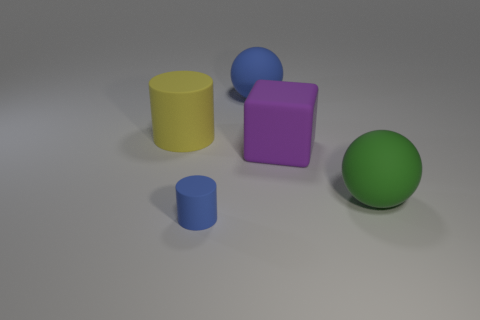What color is the rubber cylinder that is the same size as the matte cube? yellow 